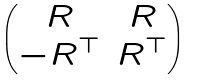<formula> <loc_0><loc_0><loc_500><loc_500>\begin{pmatrix} R & R \\ - R ^ { \top } & R ^ { \top } \end{pmatrix}</formula> 